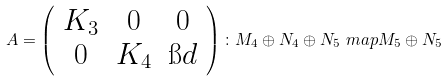<formula> <loc_0><loc_0><loc_500><loc_500>A = \left ( \begin{array} { c c c } K _ { 3 } & 0 & 0 \\ 0 & K _ { 4 } & \i d \end{array} \right ) \colon M _ { 4 } \oplus N _ { 4 } \oplus N _ { 5 } \ m a p M _ { 5 } \oplus N _ { 5 }</formula> 